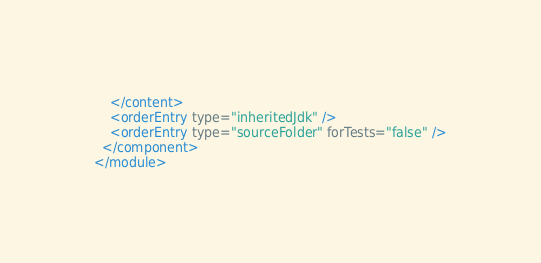<code> <loc_0><loc_0><loc_500><loc_500><_XML_>    </content>
    <orderEntry type="inheritedJdk" />
    <orderEntry type="sourceFolder" forTests="false" />
  </component>
</module></code> 